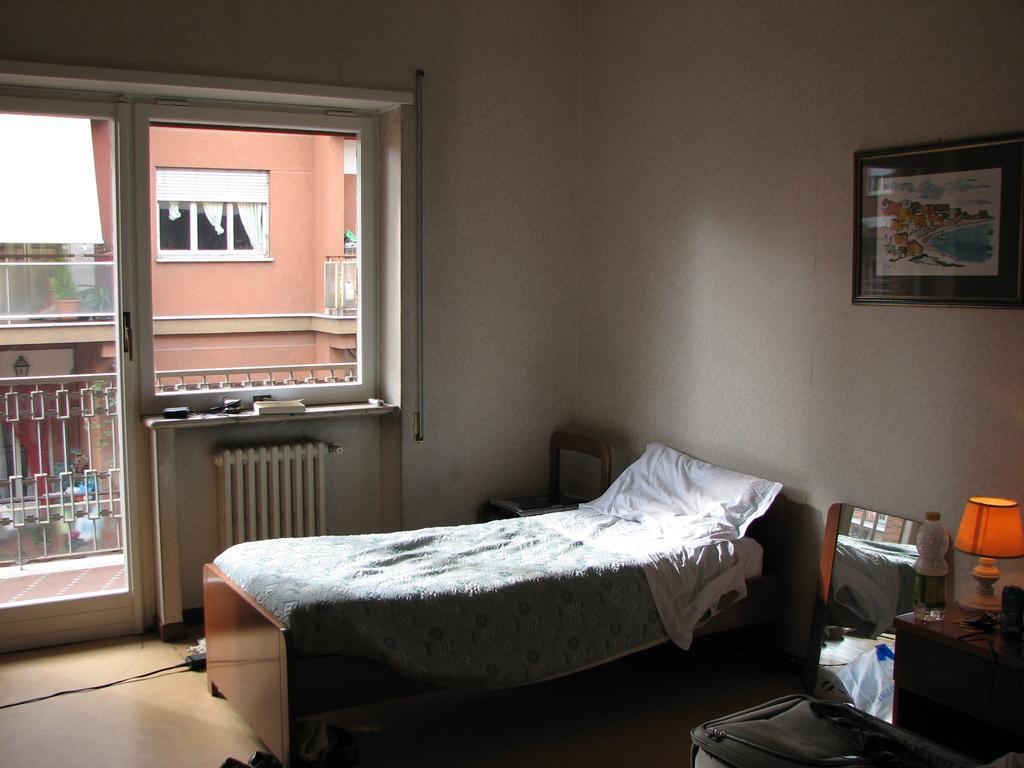Could you give a brief overview of what you see in this image? Here we can see a bed and beside that we can see a lamp placed on a table and a bottle placed on it and on the wall we can see a portrait and on the left side we can see a window and a door and we can see opposite building 